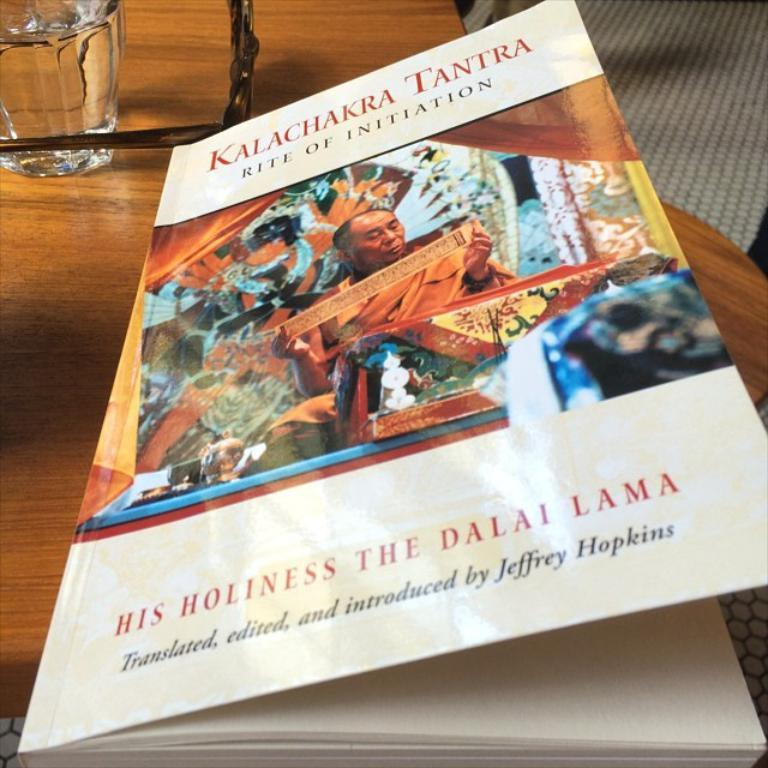Provide a one-sentence caption for the provided image. a book partially opened with the title Kalachakra Tantra. 